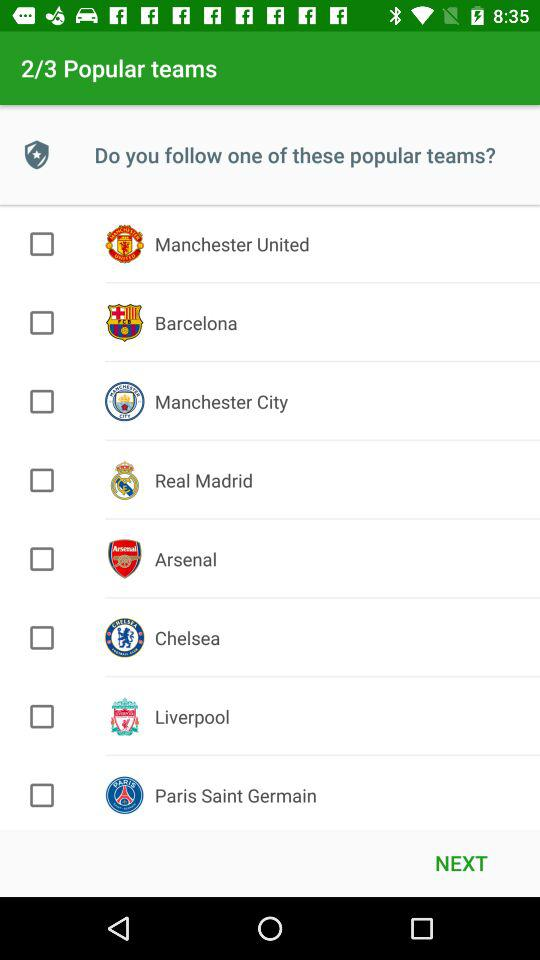How many popular teams are there?
When the provided information is insufficient, respond with <no answer>. <no answer> 